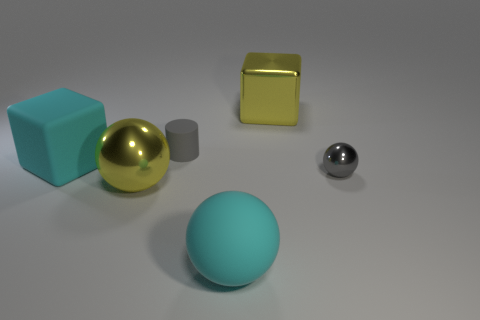Does the tiny rubber cylinder have the same color as the small ball?
Provide a succinct answer. Yes. How many other things are there of the same size as the gray cylinder?
Keep it short and to the point. 1. What is the size of the shiny sphere that is the same color as the tiny matte cylinder?
Offer a terse response. Small. Are there more large cyan objects behind the yellow metal cube than large yellow balls?
Offer a very short reply. No. Is there a tiny rubber block that has the same color as the tiny cylinder?
Give a very brief answer. No. What color is the rubber block that is the same size as the metallic cube?
Ensure brevity in your answer.  Cyan. How many large metal objects are on the left side of the big yellow shiny object behind the yellow metallic ball?
Keep it short and to the point. 1. How many objects are big metal things behind the gray metallic ball or large yellow shiny cubes?
Your answer should be very brief. 1. What number of other cylinders are made of the same material as the tiny gray cylinder?
Provide a short and direct response. 0. The rubber object that is the same color as the small ball is what shape?
Make the answer very short. Cylinder. 